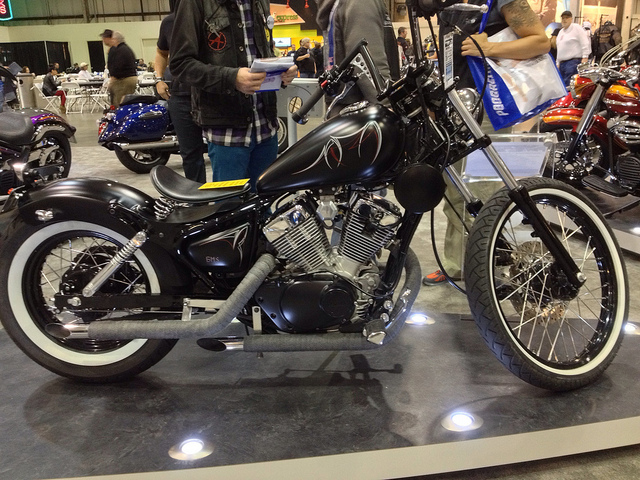<image>What brand is on the blue and white bag? I don't know the brand on the blue and white bag. It might be Harley, Brookstone, Brooks, Bonga, Power Trac, or Progressive. What brand is on the blue and white bag? I don't know what brand is on the blue and white bag. It can be either 'harley', 'brookstone', 'brooks', 'bonga', 'power trac', 'progressive', 'not sure' or 'unknown'. 